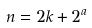<formula> <loc_0><loc_0><loc_500><loc_500>n = 2 k + 2 ^ { a }</formula> 